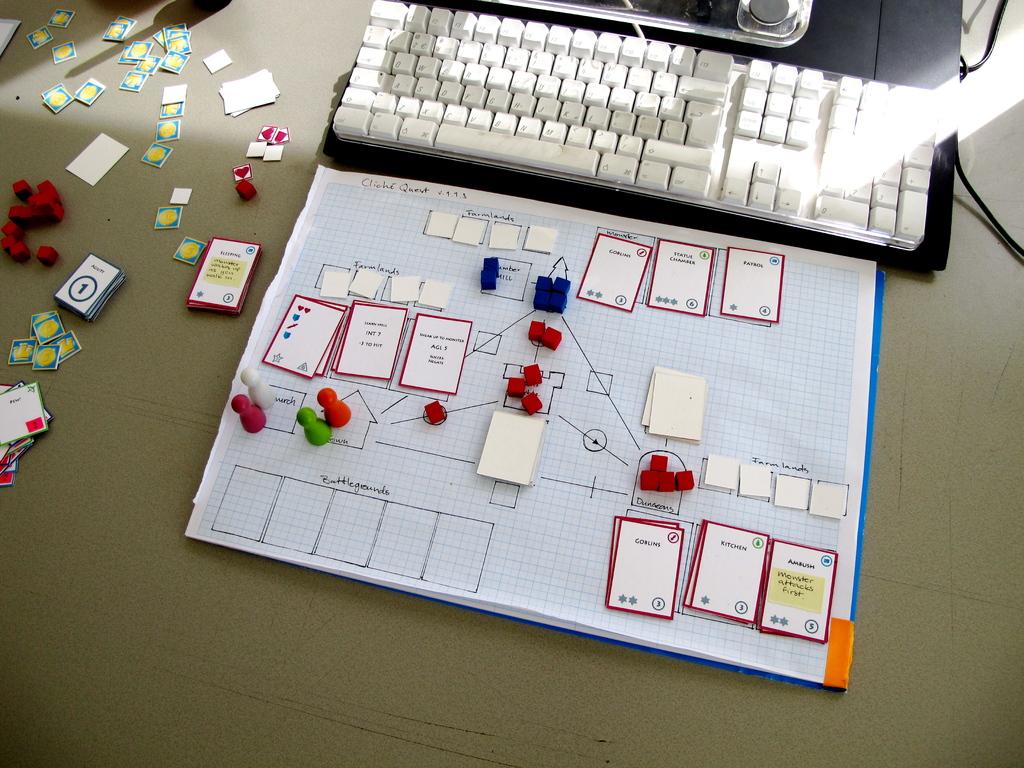What number is in the circle on the blue and white card on the left?
Provide a short and direct response. 1. 